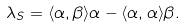Convert formula to latex. <formula><loc_0><loc_0><loc_500><loc_500>\lambda _ { S } = \langle \alpha , \beta \rangle \alpha - \langle \alpha , \alpha \rangle \beta .</formula> 